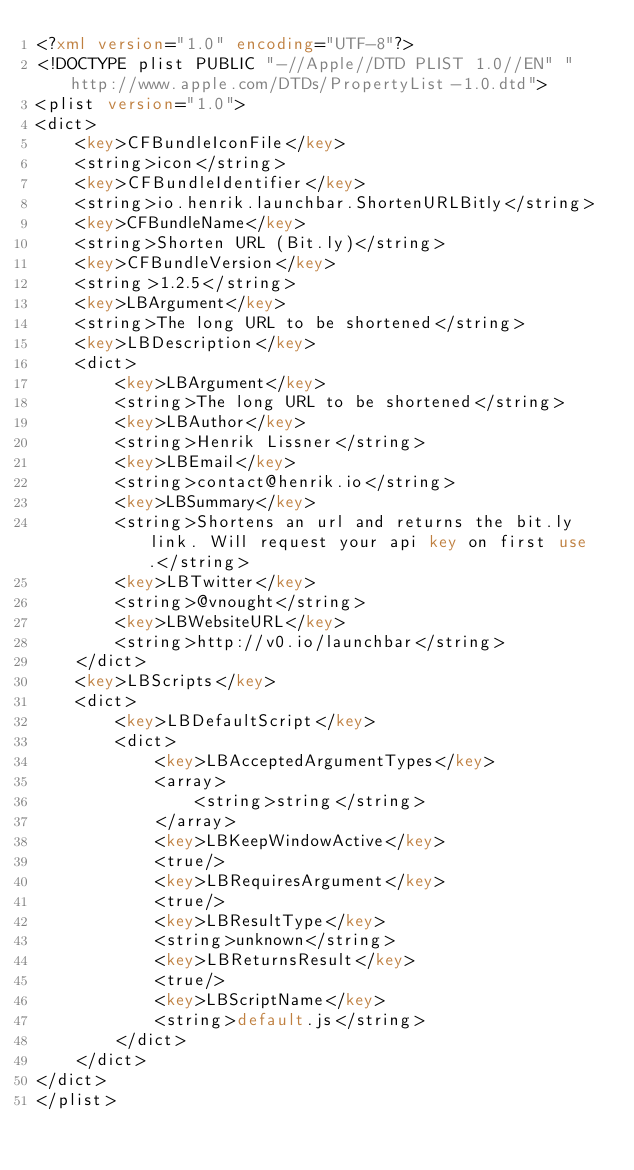<code> <loc_0><loc_0><loc_500><loc_500><_XML_><?xml version="1.0" encoding="UTF-8"?>
<!DOCTYPE plist PUBLIC "-//Apple//DTD PLIST 1.0//EN" "http://www.apple.com/DTDs/PropertyList-1.0.dtd">
<plist version="1.0">
<dict>
	<key>CFBundleIconFile</key>
	<string>icon</string>
	<key>CFBundleIdentifier</key>
	<string>io.henrik.launchbar.ShortenURLBitly</string>
	<key>CFBundleName</key>
	<string>Shorten URL (Bit.ly)</string>
	<key>CFBundleVersion</key>
	<string>1.2.5</string>
	<key>LBArgument</key>
	<string>The long URL to be shortened</string>
	<key>LBDescription</key>
	<dict>
		<key>LBArgument</key>
		<string>The long URL to be shortened</string>
		<key>LBAuthor</key>
		<string>Henrik Lissner</string>
		<key>LBEmail</key>
		<string>contact@henrik.io</string>
		<key>LBSummary</key>
		<string>Shortens an url and returns the bit.ly link. Will request your api key on first use.</string>
		<key>LBTwitter</key>
		<string>@vnought</string>
		<key>LBWebsiteURL</key>
		<string>http://v0.io/launchbar</string>
	</dict>
	<key>LBScripts</key>
	<dict>
		<key>LBDefaultScript</key>
		<dict>
			<key>LBAcceptedArgumentTypes</key>
			<array>
				<string>string</string>
			</array>
			<key>LBKeepWindowActive</key>
			<true/>
			<key>LBRequiresArgument</key>
			<true/>
			<key>LBResultType</key>
			<string>unknown</string>
			<key>LBReturnsResult</key>
			<true/>
			<key>LBScriptName</key>
			<string>default.js</string>
		</dict>
	</dict>
</dict>
</plist>
</code> 